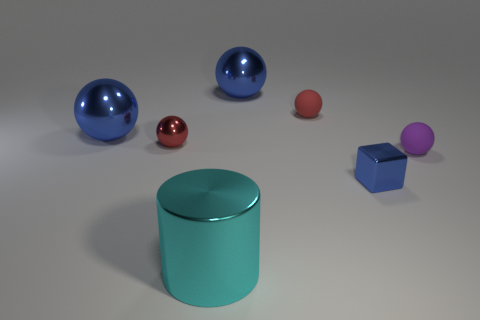Subtract 1 balls. How many balls are left? 4 Subtract all purple spheres. How many spheres are left? 4 Subtract all tiny red matte spheres. How many spheres are left? 4 Subtract all yellow spheres. Subtract all cyan cylinders. How many spheres are left? 5 Add 3 big yellow rubber balls. How many objects exist? 10 Subtract all blocks. How many objects are left? 6 Subtract all purple spheres. Subtract all small blue cubes. How many objects are left? 5 Add 6 small blocks. How many small blocks are left? 7 Add 5 large red cubes. How many large red cubes exist? 5 Subtract 0 green balls. How many objects are left? 7 